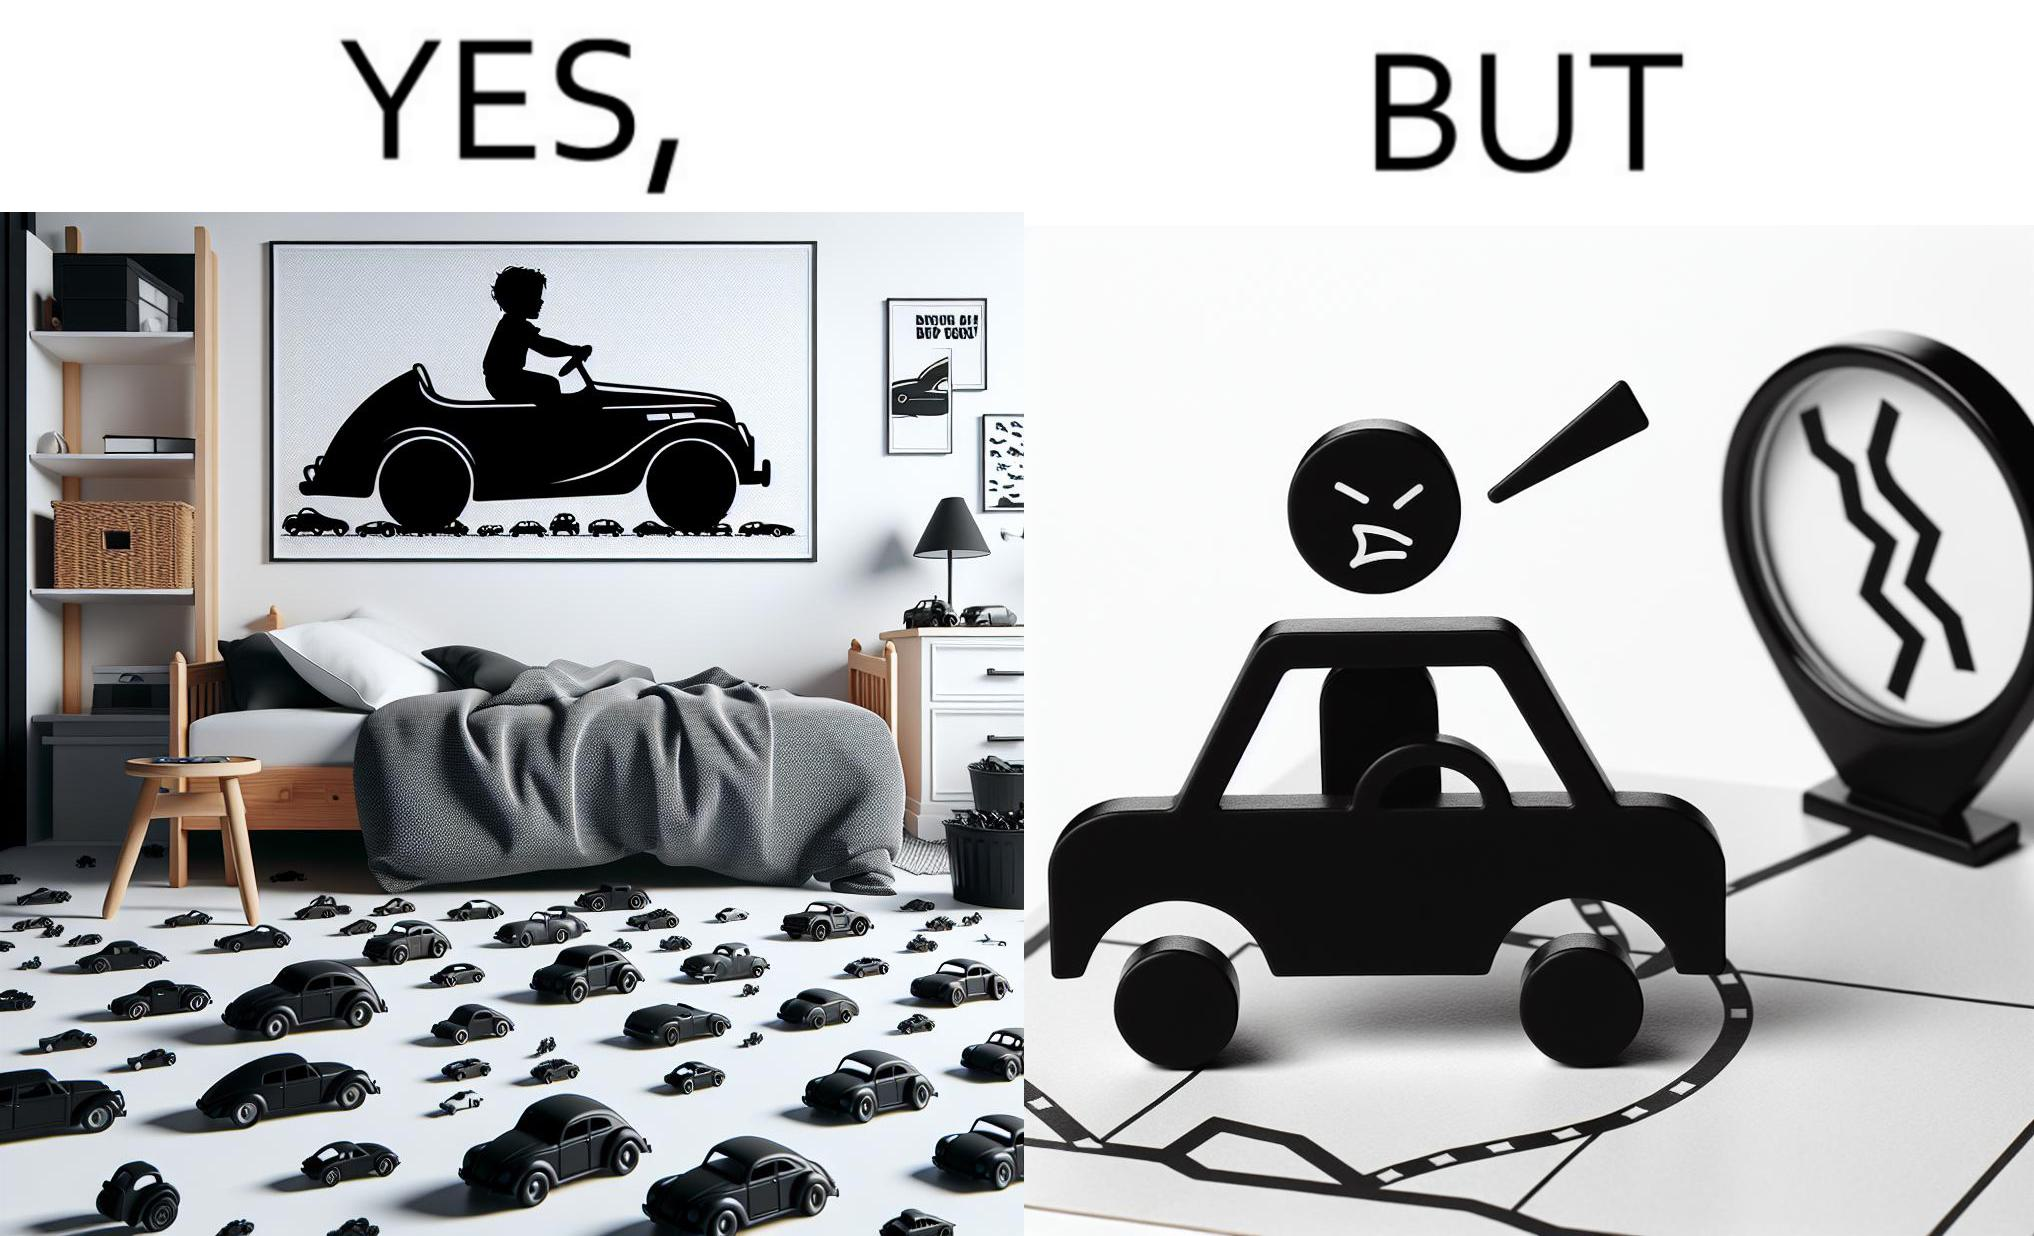Is there satirical content in this image? Yes, this image is satirical. 